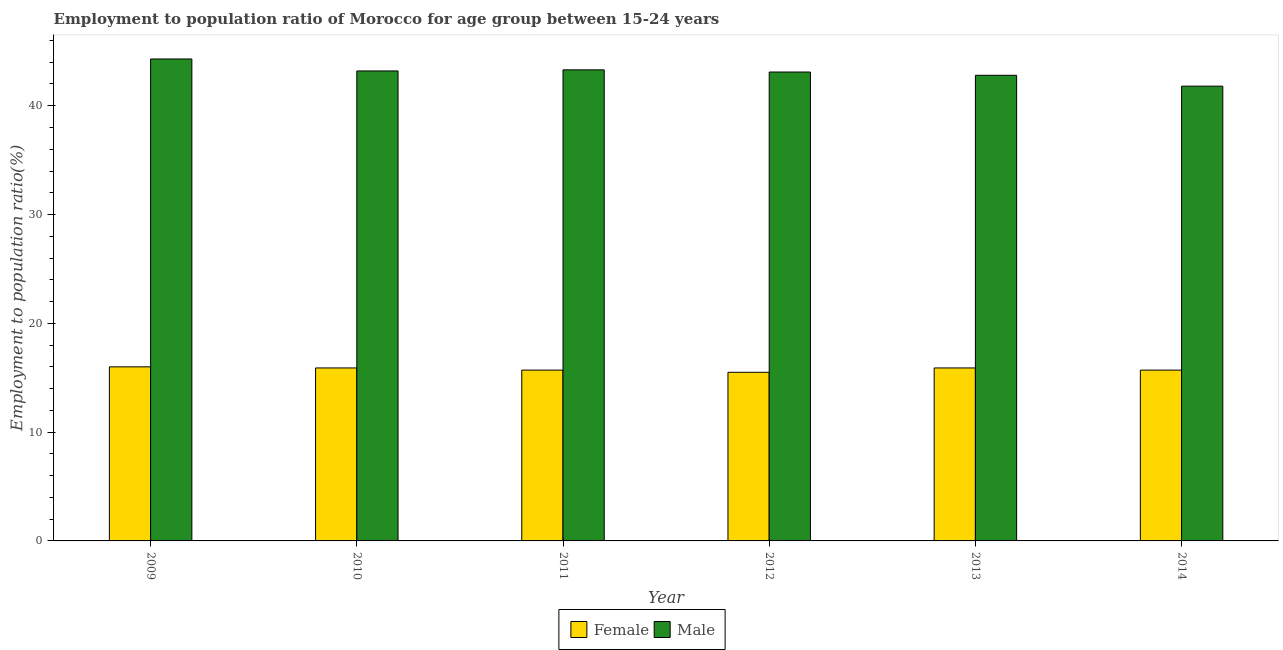How many different coloured bars are there?
Keep it short and to the point. 2. How many groups of bars are there?
Ensure brevity in your answer.  6. How many bars are there on the 3rd tick from the left?
Your answer should be compact. 2. What is the label of the 1st group of bars from the left?
Make the answer very short. 2009. In how many cases, is the number of bars for a given year not equal to the number of legend labels?
Your response must be concise. 0. What is the employment to population ratio(female) in 2014?
Offer a terse response. 15.7. Across all years, what is the maximum employment to population ratio(female)?
Ensure brevity in your answer.  16. Across all years, what is the minimum employment to population ratio(female)?
Your answer should be very brief. 15.5. In which year was the employment to population ratio(female) maximum?
Offer a very short reply. 2009. What is the total employment to population ratio(male) in the graph?
Your answer should be very brief. 258.5. What is the difference between the employment to population ratio(female) in 2011 and the employment to population ratio(male) in 2012?
Ensure brevity in your answer.  0.2. What is the average employment to population ratio(female) per year?
Your answer should be very brief. 15.78. In the year 2009, what is the difference between the employment to population ratio(female) and employment to population ratio(male)?
Provide a succinct answer. 0. What is the ratio of the employment to population ratio(female) in 2011 to that in 2014?
Provide a short and direct response. 1. What is the difference between the highest and the second highest employment to population ratio(female)?
Give a very brief answer. 0.1. How many bars are there?
Ensure brevity in your answer.  12. Are all the bars in the graph horizontal?
Provide a succinct answer. No. How many legend labels are there?
Make the answer very short. 2. How are the legend labels stacked?
Offer a very short reply. Horizontal. What is the title of the graph?
Give a very brief answer. Employment to population ratio of Morocco for age group between 15-24 years. Does "Domestic Liabilities" appear as one of the legend labels in the graph?
Ensure brevity in your answer.  No. What is the Employment to population ratio(%) in Female in 2009?
Your answer should be compact. 16. What is the Employment to population ratio(%) in Male in 2009?
Your response must be concise. 44.3. What is the Employment to population ratio(%) of Female in 2010?
Keep it short and to the point. 15.9. What is the Employment to population ratio(%) of Male in 2010?
Give a very brief answer. 43.2. What is the Employment to population ratio(%) in Female in 2011?
Provide a short and direct response. 15.7. What is the Employment to population ratio(%) of Male in 2011?
Ensure brevity in your answer.  43.3. What is the Employment to population ratio(%) in Male in 2012?
Your response must be concise. 43.1. What is the Employment to population ratio(%) in Female in 2013?
Provide a short and direct response. 15.9. What is the Employment to population ratio(%) in Male in 2013?
Keep it short and to the point. 42.8. What is the Employment to population ratio(%) of Female in 2014?
Offer a very short reply. 15.7. What is the Employment to population ratio(%) in Male in 2014?
Provide a succinct answer. 41.8. Across all years, what is the maximum Employment to population ratio(%) in Male?
Offer a very short reply. 44.3. Across all years, what is the minimum Employment to population ratio(%) in Male?
Your response must be concise. 41.8. What is the total Employment to population ratio(%) of Female in the graph?
Provide a short and direct response. 94.7. What is the total Employment to population ratio(%) in Male in the graph?
Your answer should be very brief. 258.5. What is the difference between the Employment to population ratio(%) of Male in 2009 and that in 2011?
Offer a very short reply. 1. What is the difference between the Employment to population ratio(%) of Female in 2009 and that in 2012?
Provide a short and direct response. 0.5. What is the difference between the Employment to population ratio(%) in Male in 2009 and that in 2013?
Offer a terse response. 1.5. What is the difference between the Employment to population ratio(%) in Female in 2009 and that in 2014?
Your response must be concise. 0.3. What is the difference between the Employment to population ratio(%) in Male in 2010 and that in 2011?
Offer a very short reply. -0.1. What is the difference between the Employment to population ratio(%) of Male in 2010 and that in 2012?
Keep it short and to the point. 0.1. What is the difference between the Employment to population ratio(%) of Female in 2010 and that in 2013?
Provide a succinct answer. 0. What is the difference between the Employment to population ratio(%) in Male in 2010 and that in 2014?
Provide a short and direct response. 1.4. What is the difference between the Employment to population ratio(%) of Male in 2011 and that in 2013?
Offer a very short reply. 0.5. What is the difference between the Employment to population ratio(%) of Female in 2012 and that in 2013?
Your answer should be very brief. -0.4. What is the difference between the Employment to population ratio(%) in Male in 2012 and that in 2013?
Provide a succinct answer. 0.3. What is the difference between the Employment to population ratio(%) of Female in 2009 and the Employment to population ratio(%) of Male in 2010?
Offer a very short reply. -27.2. What is the difference between the Employment to population ratio(%) in Female in 2009 and the Employment to population ratio(%) in Male in 2011?
Your answer should be very brief. -27.3. What is the difference between the Employment to population ratio(%) in Female in 2009 and the Employment to population ratio(%) in Male in 2012?
Provide a succinct answer. -27.1. What is the difference between the Employment to population ratio(%) of Female in 2009 and the Employment to population ratio(%) of Male in 2013?
Your answer should be very brief. -26.8. What is the difference between the Employment to population ratio(%) in Female in 2009 and the Employment to population ratio(%) in Male in 2014?
Provide a short and direct response. -25.8. What is the difference between the Employment to population ratio(%) in Female in 2010 and the Employment to population ratio(%) in Male in 2011?
Your answer should be compact. -27.4. What is the difference between the Employment to population ratio(%) in Female in 2010 and the Employment to population ratio(%) in Male in 2012?
Your response must be concise. -27.2. What is the difference between the Employment to population ratio(%) in Female in 2010 and the Employment to population ratio(%) in Male in 2013?
Your response must be concise. -26.9. What is the difference between the Employment to population ratio(%) in Female in 2010 and the Employment to population ratio(%) in Male in 2014?
Offer a terse response. -25.9. What is the difference between the Employment to population ratio(%) in Female in 2011 and the Employment to population ratio(%) in Male in 2012?
Ensure brevity in your answer.  -27.4. What is the difference between the Employment to population ratio(%) in Female in 2011 and the Employment to population ratio(%) in Male in 2013?
Ensure brevity in your answer.  -27.1. What is the difference between the Employment to population ratio(%) in Female in 2011 and the Employment to population ratio(%) in Male in 2014?
Provide a short and direct response. -26.1. What is the difference between the Employment to population ratio(%) in Female in 2012 and the Employment to population ratio(%) in Male in 2013?
Your answer should be very brief. -27.3. What is the difference between the Employment to population ratio(%) in Female in 2012 and the Employment to population ratio(%) in Male in 2014?
Your response must be concise. -26.3. What is the difference between the Employment to population ratio(%) in Female in 2013 and the Employment to population ratio(%) in Male in 2014?
Ensure brevity in your answer.  -25.9. What is the average Employment to population ratio(%) in Female per year?
Offer a terse response. 15.78. What is the average Employment to population ratio(%) of Male per year?
Keep it short and to the point. 43.08. In the year 2009, what is the difference between the Employment to population ratio(%) of Female and Employment to population ratio(%) of Male?
Provide a succinct answer. -28.3. In the year 2010, what is the difference between the Employment to population ratio(%) in Female and Employment to population ratio(%) in Male?
Your answer should be compact. -27.3. In the year 2011, what is the difference between the Employment to population ratio(%) in Female and Employment to population ratio(%) in Male?
Make the answer very short. -27.6. In the year 2012, what is the difference between the Employment to population ratio(%) in Female and Employment to population ratio(%) in Male?
Provide a short and direct response. -27.6. In the year 2013, what is the difference between the Employment to population ratio(%) in Female and Employment to population ratio(%) in Male?
Keep it short and to the point. -26.9. In the year 2014, what is the difference between the Employment to population ratio(%) in Female and Employment to population ratio(%) in Male?
Provide a short and direct response. -26.1. What is the ratio of the Employment to population ratio(%) in Male in 2009 to that in 2010?
Provide a short and direct response. 1.03. What is the ratio of the Employment to population ratio(%) of Female in 2009 to that in 2011?
Your response must be concise. 1.02. What is the ratio of the Employment to population ratio(%) in Male in 2009 to that in 2011?
Keep it short and to the point. 1.02. What is the ratio of the Employment to population ratio(%) of Female in 2009 to that in 2012?
Give a very brief answer. 1.03. What is the ratio of the Employment to population ratio(%) of Male in 2009 to that in 2012?
Ensure brevity in your answer.  1.03. What is the ratio of the Employment to population ratio(%) of Female in 2009 to that in 2013?
Your answer should be compact. 1.01. What is the ratio of the Employment to population ratio(%) of Male in 2009 to that in 2013?
Provide a short and direct response. 1.03. What is the ratio of the Employment to population ratio(%) in Female in 2009 to that in 2014?
Keep it short and to the point. 1.02. What is the ratio of the Employment to population ratio(%) in Male in 2009 to that in 2014?
Offer a very short reply. 1.06. What is the ratio of the Employment to population ratio(%) of Female in 2010 to that in 2011?
Make the answer very short. 1.01. What is the ratio of the Employment to population ratio(%) in Male in 2010 to that in 2011?
Your answer should be compact. 1. What is the ratio of the Employment to population ratio(%) in Female in 2010 to that in 2012?
Offer a terse response. 1.03. What is the ratio of the Employment to population ratio(%) in Female in 2010 to that in 2013?
Your response must be concise. 1. What is the ratio of the Employment to population ratio(%) in Male in 2010 to that in 2013?
Your answer should be very brief. 1.01. What is the ratio of the Employment to population ratio(%) in Female in 2010 to that in 2014?
Provide a short and direct response. 1.01. What is the ratio of the Employment to population ratio(%) of Male in 2010 to that in 2014?
Your answer should be compact. 1.03. What is the ratio of the Employment to population ratio(%) in Female in 2011 to that in 2012?
Your answer should be compact. 1.01. What is the ratio of the Employment to population ratio(%) in Male in 2011 to that in 2012?
Your answer should be very brief. 1. What is the ratio of the Employment to population ratio(%) of Female in 2011 to that in 2013?
Your answer should be compact. 0.99. What is the ratio of the Employment to population ratio(%) of Male in 2011 to that in 2013?
Offer a very short reply. 1.01. What is the ratio of the Employment to population ratio(%) of Female in 2011 to that in 2014?
Provide a succinct answer. 1. What is the ratio of the Employment to population ratio(%) in Male in 2011 to that in 2014?
Ensure brevity in your answer.  1.04. What is the ratio of the Employment to population ratio(%) of Female in 2012 to that in 2013?
Ensure brevity in your answer.  0.97. What is the ratio of the Employment to population ratio(%) of Male in 2012 to that in 2013?
Your answer should be very brief. 1.01. What is the ratio of the Employment to population ratio(%) in Female in 2012 to that in 2014?
Your answer should be compact. 0.99. What is the ratio of the Employment to population ratio(%) in Male in 2012 to that in 2014?
Provide a succinct answer. 1.03. What is the ratio of the Employment to population ratio(%) in Female in 2013 to that in 2014?
Provide a succinct answer. 1.01. What is the ratio of the Employment to population ratio(%) in Male in 2013 to that in 2014?
Offer a very short reply. 1.02. 